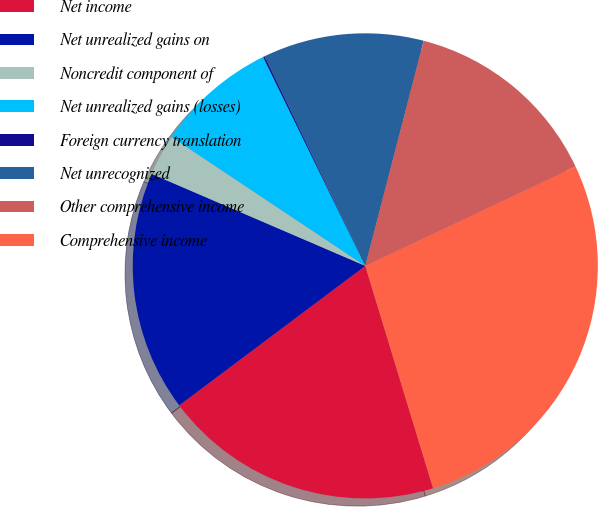<chart> <loc_0><loc_0><loc_500><loc_500><pie_chart><fcel>Net income<fcel>Net unrealized gains on<fcel>Noncredit component of<fcel>Net unrealized gains (losses)<fcel>Foreign currency translation<fcel>Net unrecognized<fcel>Other comprehensive income<fcel>Comprehensive income<nl><fcel>19.47%<fcel>16.71%<fcel>2.88%<fcel>8.41%<fcel>0.11%<fcel>11.17%<fcel>13.94%<fcel>27.31%<nl></chart> 